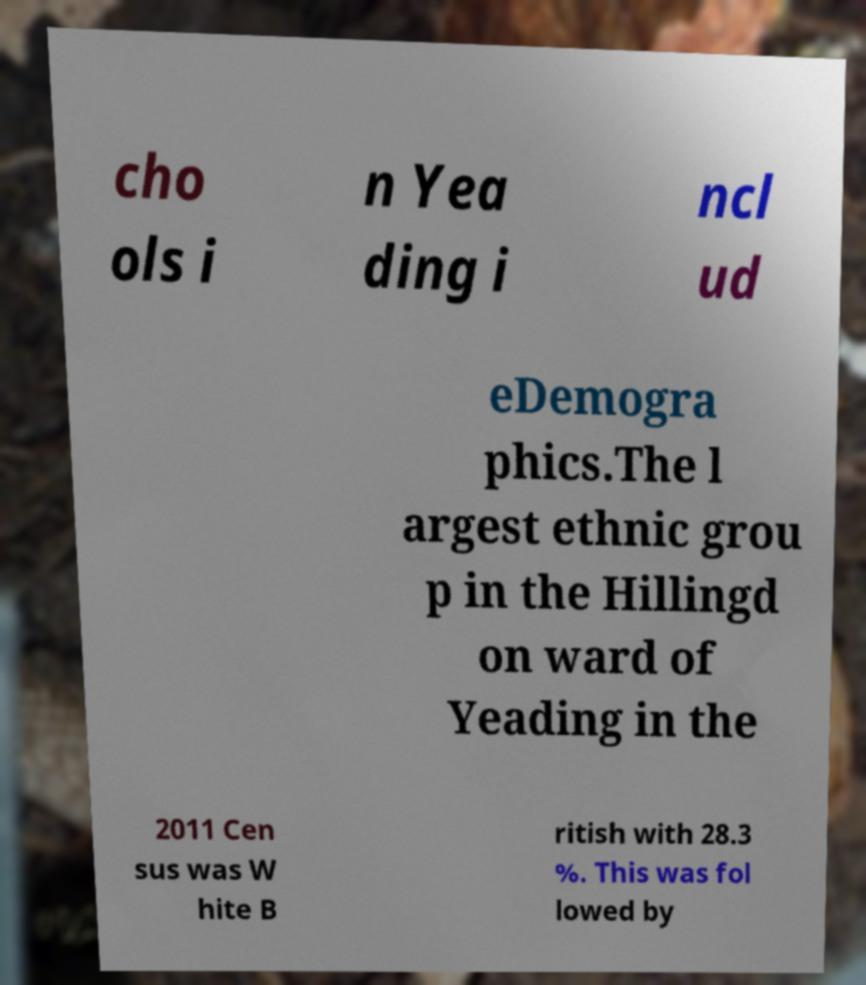Could you assist in decoding the text presented in this image and type it out clearly? cho ols i n Yea ding i ncl ud eDemogra phics.The l argest ethnic grou p in the Hillingd on ward of Yeading in the 2011 Cen sus was W hite B ritish with 28.3 %. This was fol lowed by 